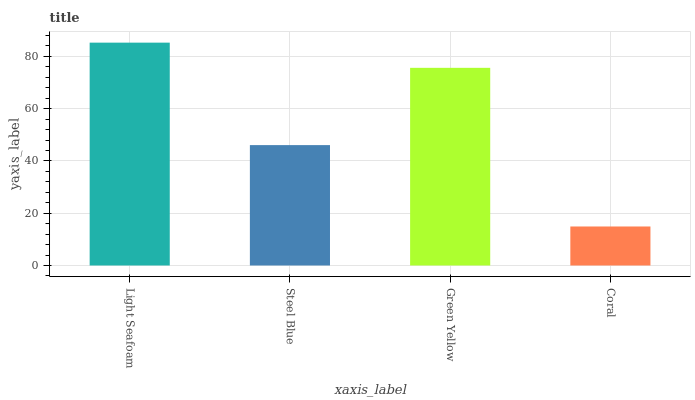Is Coral the minimum?
Answer yes or no. Yes. Is Light Seafoam the maximum?
Answer yes or no. Yes. Is Steel Blue the minimum?
Answer yes or no. No. Is Steel Blue the maximum?
Answer yes or no. No. Is Light Seafoam greater than Steel Blue?
Answer yes or no. Yes. Is Steel Blue less than Light Seafoam?
Answer yes or no. Yes. Is Steel Blue greater than Light Seafoam?
Answer yes or no. No. Is Light Seafoam less than Steel Blue?
Answer yes or no. No. Is Green Yellow the high median?
Answer yes or no. Yes. Is Steel Blue the low median?
Answer yes or no. Yes. Is Light Seafoam the high median?
Answer yes or no. No. Is Light Seafoam the low median?
Answer yes or no. No. 